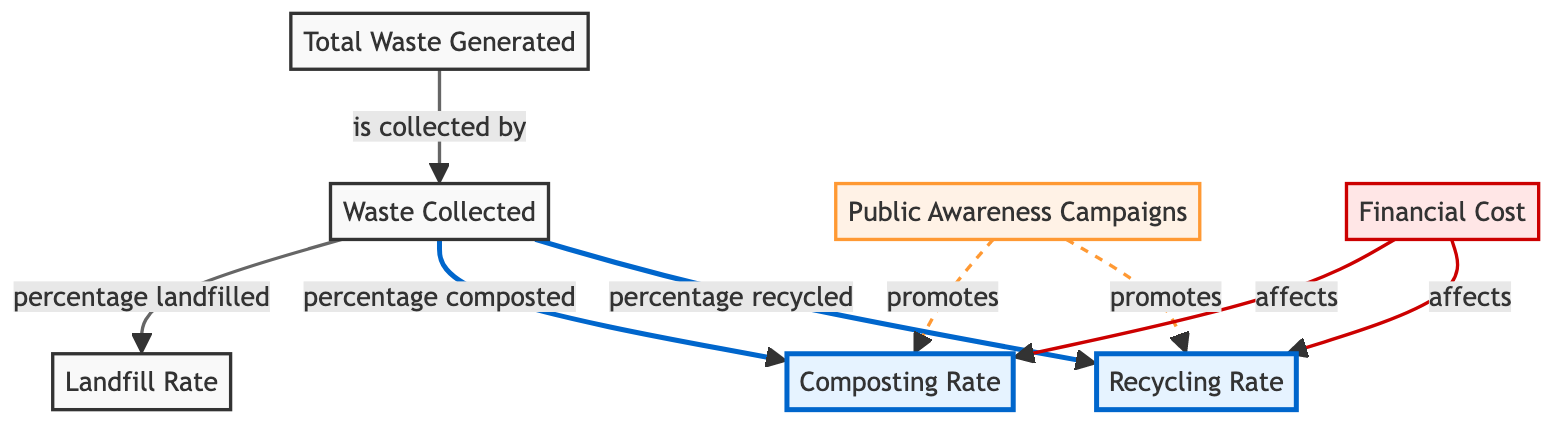What is the relationship between total waste generated and waste collected? The diagram shows a direct arrow from "Total Waste Generated" to "Waste Collected", indicating that total waste generated is collected by the waste collection system.
Answer: is collected by What node represents the recycling rate in the diagram? The node labeled "Recycling Rate" is clearly designated in the diagram with a focus class, making it stand out visually as the metric being examined.
Answer: Recycling Rate How many nodes are categorized as 'cost' in the diagram? There is one node labeled "Financial Cost" categorized under 'cost', indicating that there is only a single focus on financial aspects affecting waste management efficiency.
Answer: 1 What does the public awareness campaigns promote in the diagram? The diagram illustrates that "Public Awareness Campaigns" have arrows that lead to both "Recycling Rate" and "Composting Rate", indicating these are the two metrics being promoted.
Answer: recycling rate and composting rate How does financial cost affect the recycling and composting rates? The diagram indicates two distinct arrows going from "Financial Cost" to both "Recycling Rate" and "Composting Rate", suggesting that financial costs have a direct impact on both rates.
Answer: affects both rates 